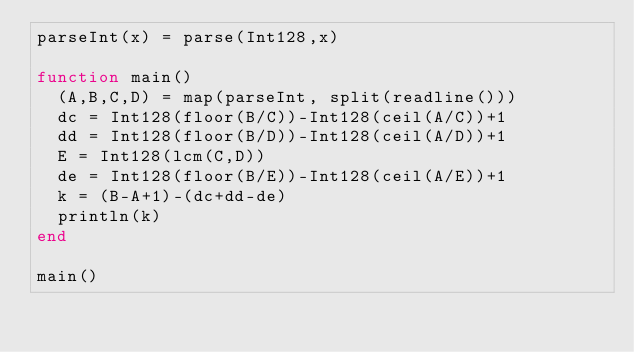<code> <loc_0><loc_0><loc_500><loc_500><_Julia_>parseInt(x) = parse(Int128,x)

function main()
  (A,B,C,D) = map(parseInt, split(readline()))
  dc = Int128(floor(B/C))-Int128(ceil(A/C))+1
  dd = Int128(floor(B/D))-Int128(ceil(A/D))+1
  E = Int128(lcm(C,D))
  de = Int128(floor(B/E))-Int128(ceil(A/E))+1
  k = (B-A+1)-(dc+dd-de)
  println(k)
end

main()</code> 